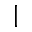<formula> <loc_0><loc_0><loc_500><loc_500>|</formula> 